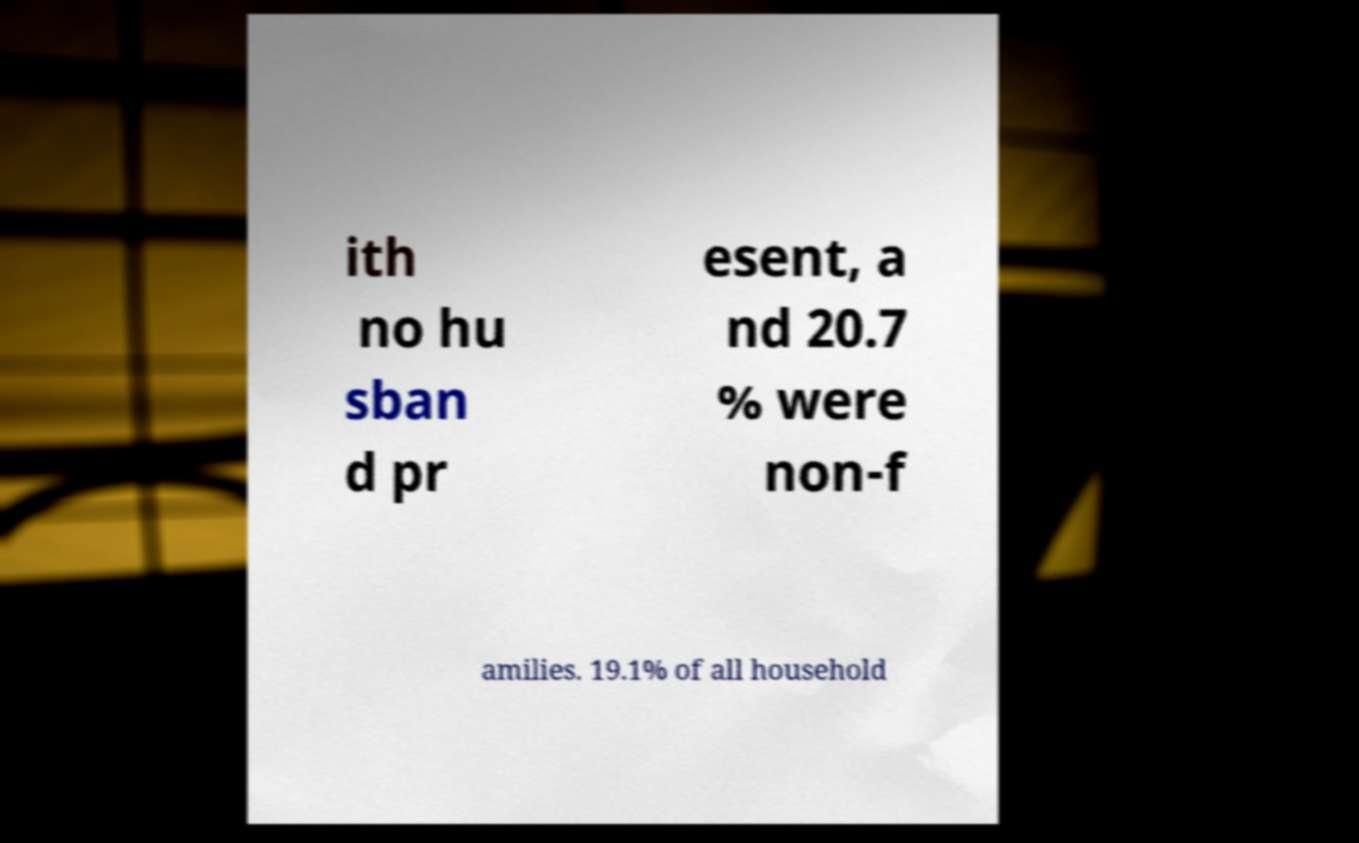Please read and relay the text visible in this image. What does it say? ith no hu sban d pr esent, a nd 20.7 % were non-f amilies. 19.1% of all household 